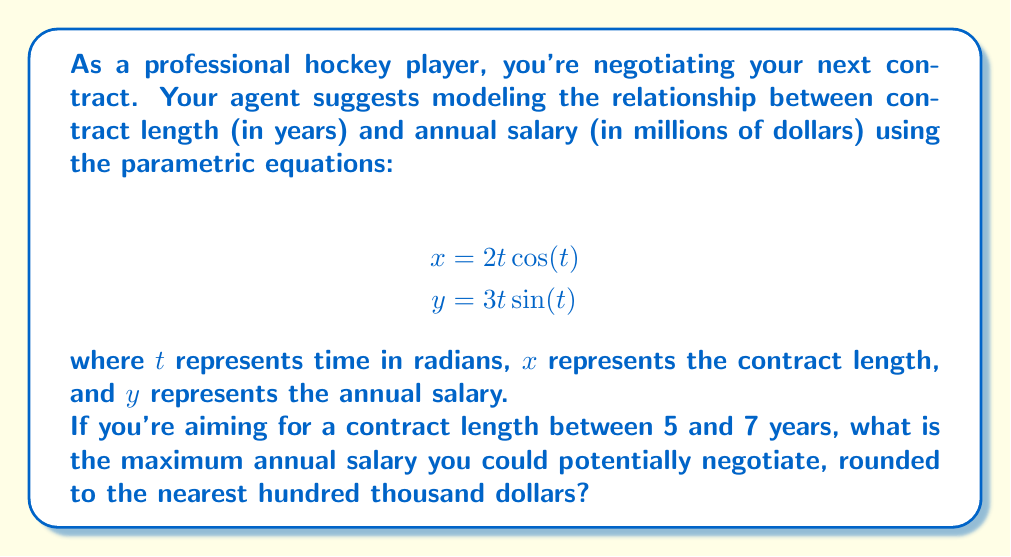What is the answer to this math problem? To solve this problem, we need to follow these steps:

1) First, we need to determine the range of $t$ that corresponds to contract lengths between 5 and 7 years. We can do this by solving the equation:

   $$5 \leq 2t \cos(t) \leq 7$$

2) Solving this inequality analytically is complex, so we can use numerical methods or graphing to find that this corresponds approximately to $1.8 \leq t \leq 2.2$.

3) Now, we need to find the maximum value of $y = 3t \sin(t)$ within this range of $t$.

4) We can do this by calculating the derivative of $y$ with respect to $t$:

   $$\frac{dy}{dt} = 3\sin(t) + 3t\cos(t)$$

5) Setting this equal to zero and solving for $t$ within our range:

   $$3\sin(t) + 3t\cos(t) = 0$$
   $$\sin(t) + t\cos(t) = 0$$

   This equation is satisfied when $t \approx 2.029$.

6) To confirm this is a maximum (not a minimum), we can check the second derivative or observe the function's behavior.

7) Now we can calculate the maximum salary by plugging this $t$ value into the $y$ equation:

   $$y = 3(2.029)\sin(2.029) \approx 5.7323$$

8) Rounding to the nearest hundred thousand dollars gives us $5.7 million.
Answer: The maximum annual salary you could potentially negotiate for a contract length between 5 and 7 years is $5.7 million. 